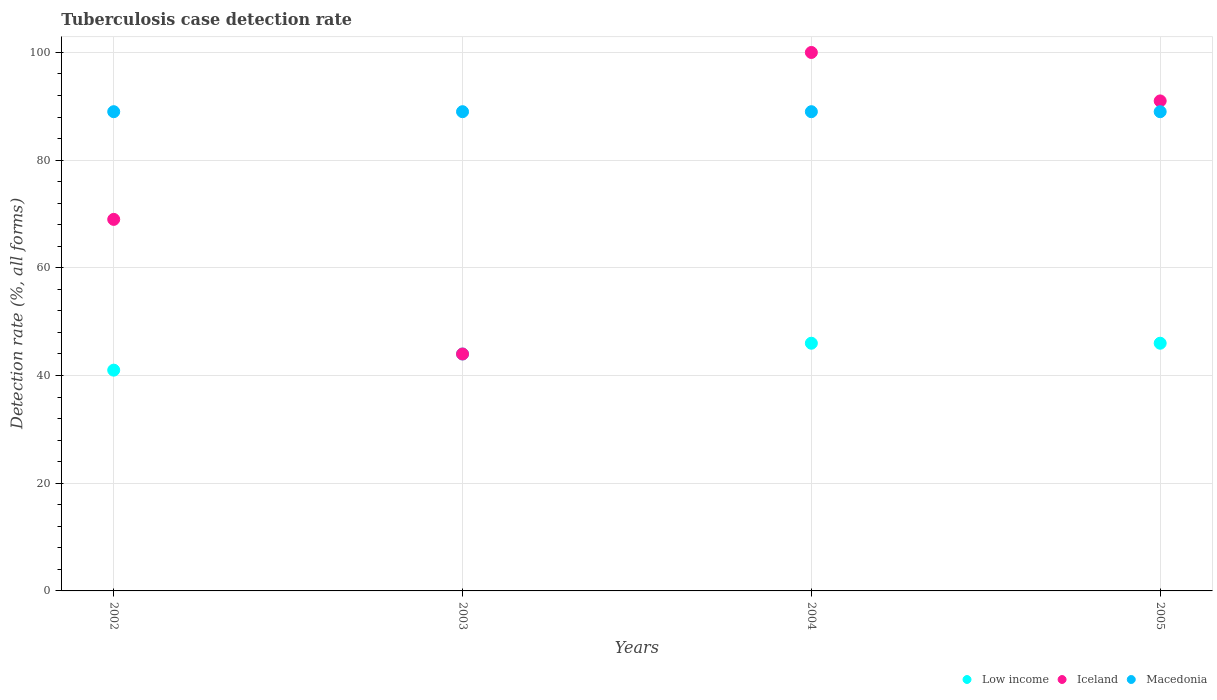How many different coloured dotlines are there?
Give a very brief answer. 3. What is the tuberculosis case detection rate in in Macedonia in 2005?
Offer a terse response. 89. Across all years, what is the maximum tuberculosis case detection rate in in Low income?
Make the answer very short. 46. Across all years, what is the minimum tuberculosis case detection rate in in Macedonia?
Ensure brevity in your answer.  89. In which year was the tuberculosis case detection rate in in Low income minimum?
Your response must be concise. 2002. What is the total tuberculosis case detection rate in in Low income in the graph?
Make the answer very short. 177. What is the difference between the tuberculosis case detection rate in in Iceland in 2002 and that in 2003?
Offer a very short reply. 25. What is the difference between the tuberculosis case detection rate in in Low income in 2004 and the tuberculosis case detection rate in in Macedonia in 2003?
Ensure brevity in your answer.  -43. What is the average tuberculosis case detection rate in in Low income per year?
Ensure brevity in your answer.  44.25. In the year 2002, what is the difference between the tuberculosis case detection rate in in Iceland and tuberculosis case detection rate in in Low income?
Provide a short and direct response. 28. Is the tuberculosis case detection rate in in Macedonia in 2004 less than that in 2005?
Your answer should be very brief. No. What is the difference between the highest and the lowest tuberculosis case detection rate in in Iceland?
Make the answer very short. 56. Is the tuberculosis case detection rate in in Iceland strictly less than the tuberculosis case detection rate in in Macedonia over the years?
Make the answer very short. No. How many years are there in the graph?
Your answer should be very brief. 4. What is the difference between two consecutive major ticks on the Y-axis?
Ensure brevity in your answer.  20. Are the values on the major ticks of Y-axis written in scientific E-notation?
Provide a short and direct response. No. Does the graph contain grids?
Offer a very short reply. Yes. How many legend labels are there?
Ensure brevity in your answer.  3. What is the title of the graph?
Give a very brief answer. Tuberculosis case detection rate. Does "Qatar" appear as one of the legend labels in the graph?
Your answer should be compact. No. What is the label or title of the Y-axis?
Provide a short and direct response. Detection rate (%, all forms). What is the Detection rate (%, all forms) of Macedonia in 2002?
Ensure brevity in your answer.  89. What is the Detection rate (%, all forms) in Iceland in 2003?
Make the answer very short. 44. What is the Detection rate (%, all forms) in Macedonia in 2003?
Your answer should be compact. 89. What is the Detection rate (%, all forms) in Macedonia in 2004?
Make the answer very short. 89. What is the Detection rate (%, all forms) in Iceland in 2005?
Make the answer very short. 91. What is the Detection rate (%, all forms) in Macedonia in 2005?
Ensure brevity in your answer.  89. Across all years, what is the maximum Detection rate (%, all forms) of Macedonia?
Your answer should be compact. 89. Across all years, what is the minimum Detection rate (%, all forms) in Macedonia?
Provide a short and direct response. 89. What is the total Detection rate (%, all forms) in Low income in the graph?
Give a very brief answer. 177. What is the total Detection rate (%, all forms) in Iceland in the graph?
Offer a very short reply. 304. What is the total Detection rate (%, all forms) of Macedonia in the graph?
Offer a terse response. 356. What is the difference between the Detection rate (%, all forms) of Iceland in 2002 and that in 2003?
Ensure brevity in your answer.  25. What is the difference between the Detection rate (%, all forms) in Macedonia in 2002 and that in 2003?
Your response must be concise. 0. What is the difference between the Detection rate (%, all forms) in Iceland in 2002 and that in 2004?
Provide a succinct answer. -31. What is the difference between the Detection rate (%, all forms) of Low income in 2002 and that in 2005?
Ensure brevity in your answer.  -5. What is the difference between the Detection rate (%, all forms) in Iceland in 2002 and that in 2005?
Provide a short and direct response. -22. What is the difference between the Detection rate (%, all forms) in Low income in 2003 and that in 2004?
Provide a succinct answer. -2. What is the difference between the Detection rate (%, all forms) in Iceland in 2003 and that in 2004?
Ensure brevity in your answer.  -56. What is the difference between the Detection rate (%, all forms) of Iceland in 2003 and that in 2005?
Provide a succinct answer. -47. What is the difference between the Detection rate (%, all forms) in Low income in 2002 and the Detection rate (%, all forms) in Macedonia in 2003?
Give a very brief answer. -48. What is the difference between the Detection rate (%, all forms) of Iceland in 2002 and the Detection rate (%, all forms) of Macedonia in 2003?
Offer a terse response. -20. What is the difference between the Detection rate (%, all forms) of Low income in 2002 and the Detection rate (%, all forms) of Iceland in 2004?
Provide a short and direct response. -59. What is the difference between the Detection rate (%, all forms) in Low income in 2002 and the Detection rate (%, all forms) in Macedonia in 2004?
Offer a terse response. -48. What is the difference between the Detection rate (%, all forms) in Iceland in 2002 and the Detection rate (%, all forms) in Macedonia in 2004?
Ensure brevity in your answer.  -20. What is the difference between the Detection rate (%, all forms) of Low income in 2002 and the Detection rate (%, all forms) of Iceland in 2005?
Give a very brief answer. -50. What is the difference between the Detection rate (%, all forms) in Low income in 2002 and the Detection rate (%, all forms) in Macedonia in 2005?
Provide a short and direct response. -48. What is the difference between the Detection rate (%, all forms) of Iceland in 2002 and the Detection rate (%, all forms) of Macedonia in 2005?
Your answer should be compact. -20. What is the difference between the Detection rate (%, all forms) of Low income in 2003 and the Detection rate (%, all forms) of Iceland in 2004?
Give a very brief answer. -56. What is the difference between the Detection rate (%, all forms) of Low income in 2003 and the Detection rate (%, all forms) of Macedonia in 2004?
Provide a succinct answer. -45. What is the difference between the Detection rate (%, all forms) in Iceland in 2003 and the Detection rate (%, all forms) in Macedonia in 2004?
Keep it short and to the point. -45. What is the difference between the Detection rate (%, all forms) in Low income in 2003 and the Detection rate (%, all forms) in Iceland in 2005?
Provide a short and direct response. -47. What is the difference between the Detection rate (%, all forms) of Low income in 2003 and the Detection rate (%, all forms) of Macedonia in 2005?
Your response must be concise. -45. What is the difference between the Detection rate (%, all forms) of Iceland in 2003 and the Detection rate (%, all forms) of Macedonia in 2005?
Your response must be concise. -45. What is the difference between the Detection rate (%, all forms) of Low income in 2004 and the Detection rate (%, all forms) of Iceland in 2005?
Ensure brevity in your answer.  -45. What is the difference between the Detection rate (%, all forms) of Low income in 2004 and the Detection rate (%, all forms) of Macedonia in 2005?
Your answer should be very brief. -43. What is the average Detection rate (%, all forms) in Low income per year?
Keep it short and to the point. 44.25. What is the average Detection rate (%, all forms) of Macedonia per year?
Offer a terse response. 89. In the year 2002, what is the difference between the Detection rate (%, all forms) in Low income and Detection rate (%, all forms) in Macedonia?
Your response must be concise. -48. In the year 2003, what is the difference between the Detection rate (%, all forms) of Low income and Detection rate (%, all forms) of Iceland?
Make the answer very short. 0. In the year 2003, what is the difference between the Detection rate (%, all forms) in Low income and Detection rate (%, all forms) in Macedonia?
Make the answer very short. -45. In the year 2003, what is the difference between the Detection rate (%, all forms) of Iceland and Detection rate (%, all forms) of Macedonia?
Keep it short and to the point. -45. In the year 2004, what is the difference between the Detection rate (%, all forms) in Low income and Detection rate (%, all forms) in Iceland?
Offer a terse response. -54. In the year 2004, what is the difference between the Detection rate (%, all forms) of Low income and Detection rate (%, all forms) of Macedonia?
Your answer should be very brief. -43. In the year 2004, what is the difference between the Detection rate (%, all forms) in Iceland and Detection rate (%, all forms) in Macedonia?
Your answer should be compact. 11. In the year 2005, what is the difference between the Detection rate (%, all forms) of Low income and Detection rate (%, all forms) of Iceland?
Your answer should be very brief. -45. In the year 2005, what is the difference between the Detection rate (%, all forms) in Low income and Detection rate (%, all forms) in Macedonia?
Give a very brief answer. -43. In the year 2005, what is the difference between the Detection rate (%, all forms) of Iceland and Detection rate (%, all forms) of Macedonia?
Provide a short and direct response. 2. What is the ratio of the Detection rate (%, all forms) in Low income in 2002 to that in 2003?
Your answer should be very brief. 0.93. What is the ratio of the Detection rate (%, all forms) of Iceland in 2002 to that in 2003?
Give a very brief answer. 1.57. What is the ratio of the Detection rate (%, all forms) in Low income in 2002 to that in 2004?
Ensure brevity in your answer.  0.89. What is the ratio of the Detection rate (%, all forms) in Iceland in 2002 to that in 2004?
Provide a succinct answer. 0.69. What is the ratio of the Detection rate (%, all forms) in Macedonia in 2002 to that in 2004?
Offer a very short reply. 1. What is the ratio of the Detection rate (%, all forms) in Low income in 2002 to that in 2005?
Provide a short and direct response. 0.89. What is the ratio of the Detection rate (%, all forms) of Iceland in 2002 to that in 2005?
Your answer should be very brief. 0.76. What is the ratio of the Detection rate (%, all forms) in Low income in 2003 to that in 2004?
Provide a short and direct response. 0.96. What is the ratio of the Detection rate (%, all forms) of Iceland in 2003 to that in 2004?
Provide a short and direct response. 0.44. What is the ratio of the Detection rate (%, all forms) of Macedonia in 2003 to that in 2004?
Offer a very short reply. 1. What is the ratio of the Detection rate (%, all forms) of Low income in 2003 to that in 2005?
Your response must be concise. 0.96. What is the ratio of the Detection rate (%, all forms) in Iceland in 2003 to that in 2005?
Provide a succinct answer. 0.48. What is the ratio of the Detection rate (%, all forms) of Macedonia in 2003 to that in 2005?
Give a very brief answer. 1. What is the ratio of the Detection rate (%, all forms) of Iceland in 2004 to that in 2005?
Offer a very short reply. 1.1. What is the ratio of the Detection rate (%, all forms) of Macedonia in 2004 to that in 2005?
Your answer should be very brief. 1. What is the difference between the highest and the second highest Detection rate (%, all forms) in Low income?
Ensure brevity in your answer.  0. What is the difference between the highest and the second highest Detection rate (%, all forms) of Iceland?
Your answer should be compact. 9. What is the difference between the highest and the lowest Detection rate (%, all forms) of Iceland?
Offer a very short reply. 56. What is the difference between the highest and the lowest Detection rate (%, all forms) of Macedonia?
Your answer should be very brief. 0. 